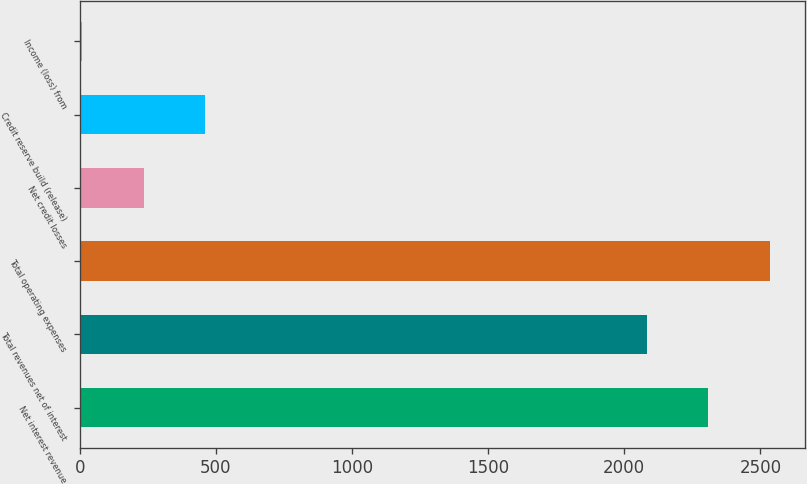Convert chart to OTSL. <chart><loc_0><loc_0><loc_500><loc_500><bar_chart><fcel>Net interest revenue<fcel>Total revenues net of interest<fcel>Total operating expenses<fcel>Net credit losses<fcel>Credit reserve build (release)<fcel>Income (loss) from<nl><fcel>2309.4<fcel>2083<fcel>2535.8<fcel>234.4<fcel>460.8<fcel>8<nl></chart> 